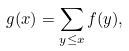Convert formula to latex. <formula><loc_0><loc_0><loc_500><loc_500>g ( x ) = \sum _ { y \leq x } f ( y ) ,</formula> 